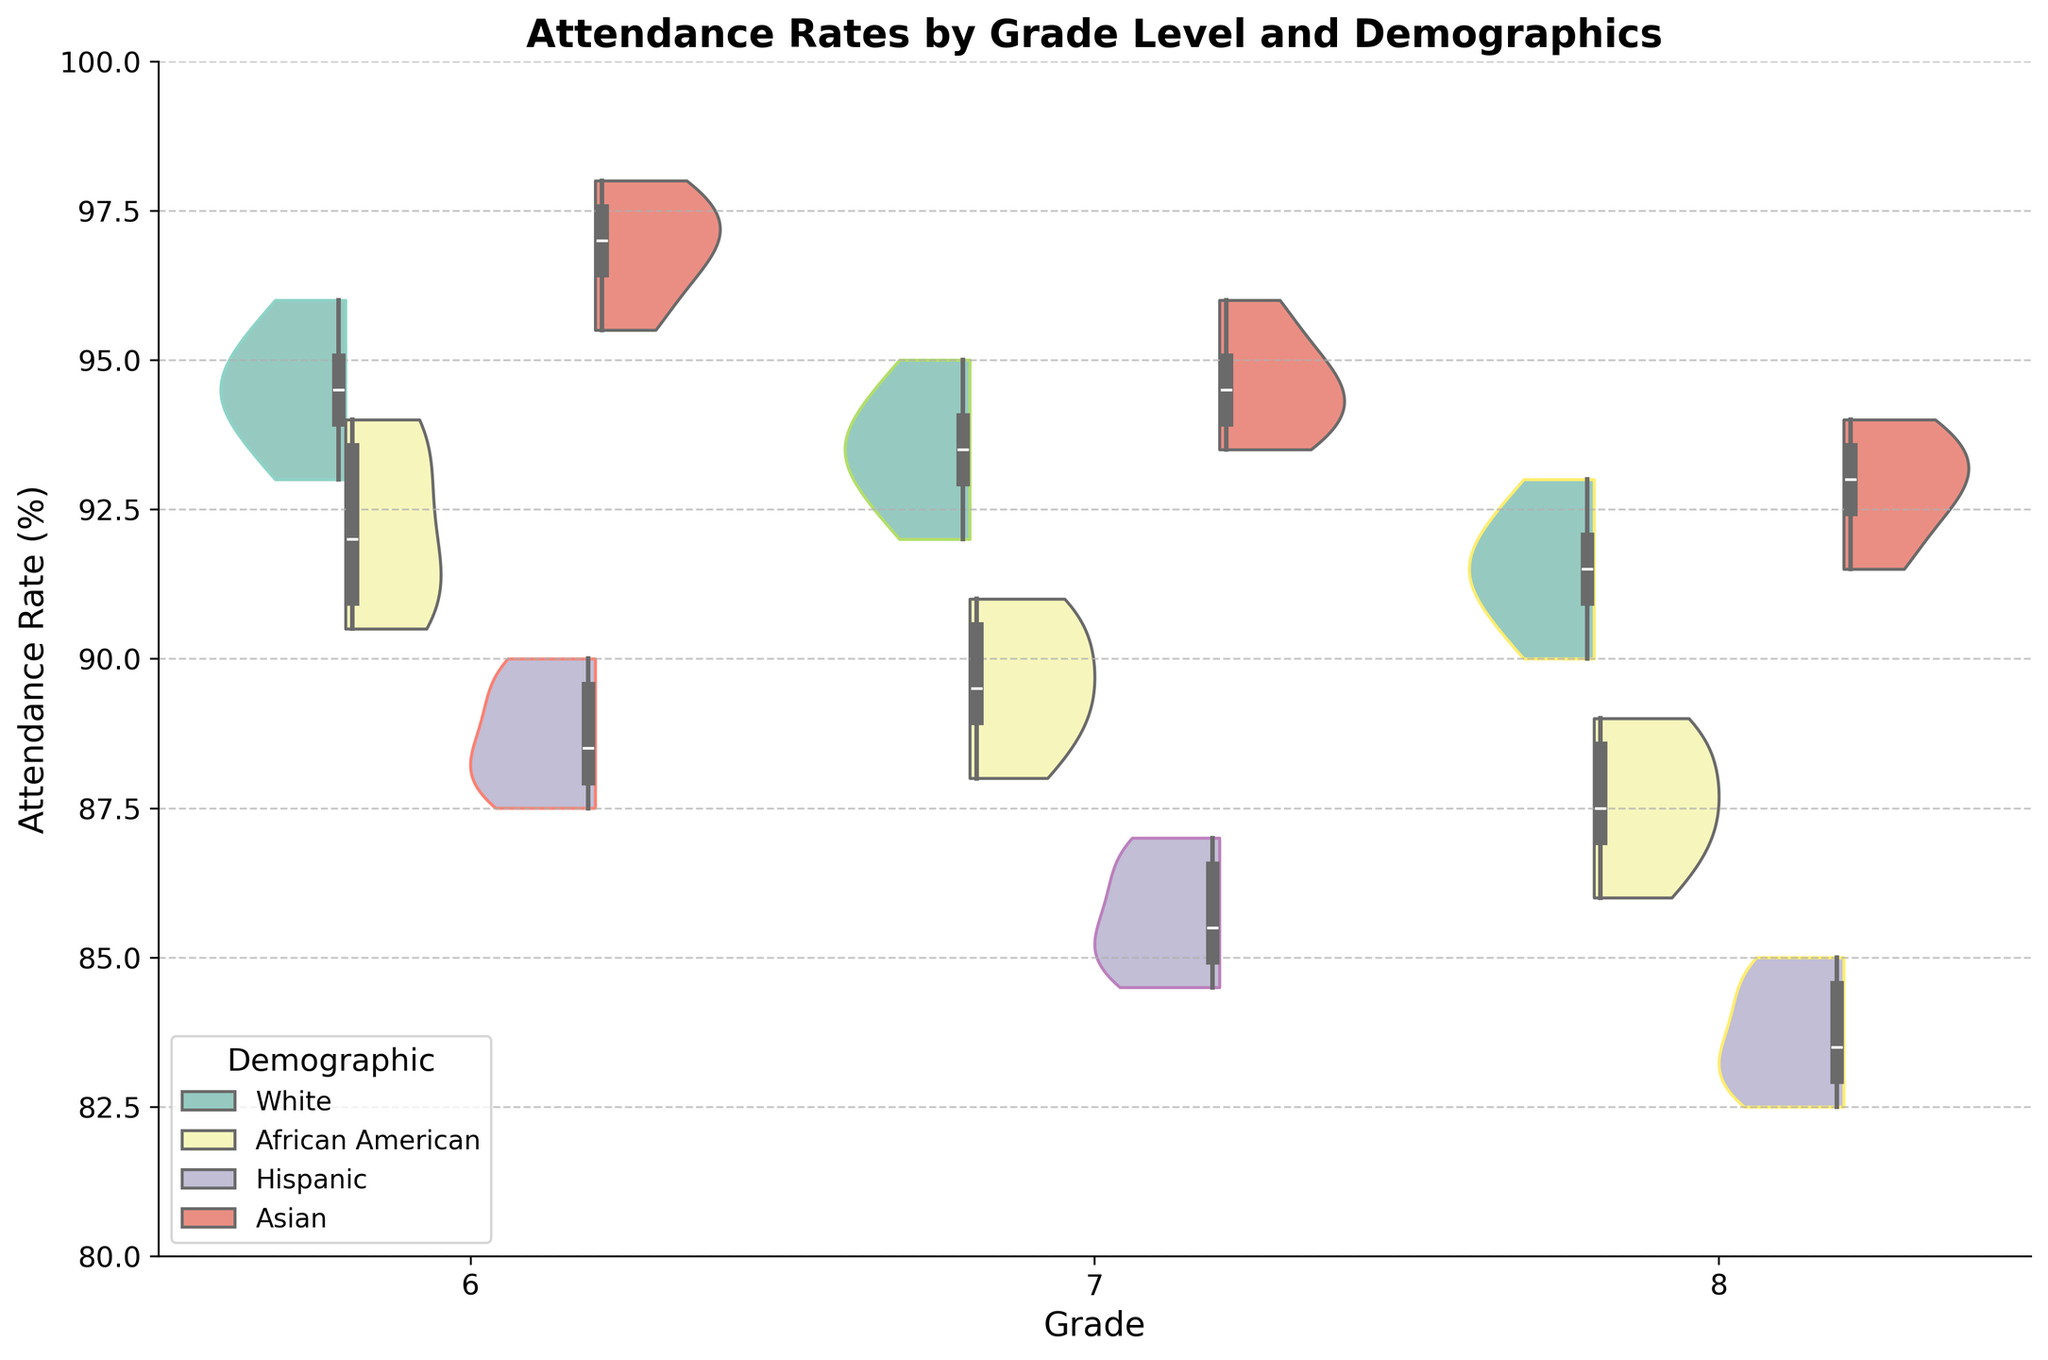What is the title of the figure? The title of the figure is displayed at the top and reads "Attendance Rates by Grade Level and Demographics".
Answer: Attendance Rates by Grade Level and Demographics Which demographic group shows the highest median attendance rate for grade 6? By observing the box plots overlaid on the violin plots, the group with the highest median attendance rate for grade 6 is the Asian demographic.
Answer: Asian How do the median attendance rates compare between the Asian and Hispanic demographics in grade 7? The box plots in the violin chart show that for grade 7, the median attendance rate for the Asian demographic is higher than that for the Hispanic demographic.
Answer: Asian median > Hispanic median What is the range of attendance rates for the African American demographic in grade 8? The range can be found by looking at the tips of the violin plot. For grade 8 African American students, the attendance rates range from 86.0% to 89.0%.
Answer: 86.0% to 89.0% Which grade's White demographic has the smallest spread in attendance rates? The spread can be determined by the width of the violin plots and the length of the box plots. The White demographic in grade 6 shows the smallest spread in attendance rates.
Answer: Grade 6 How does the attendance rate for the Hispanic demographic in grade 8 compare with the Hispanic demographic in grade 7? The median and the overall distribution can be compared directly using the violin plots. The attendance rate for the Hispanic demographic in grade 8 is lower than the Hispanic demographic in grade 7.
Answer: Grade 8 < Grade 7 Which demographic shows the widest spread of attendance rates for grade 6? By examining the width of the violin plots, the Hispanic demographic shows the widest spread of attendance rates for grade 6.
Answer: Hispanic What is the attendance rate at the lower quartile for the Asian demographic in grade 7? By examining the box plot inside the violin plot, the lower quartile (25th percentile) for the Asian demographic in grade 7 has an attendance rate around 94.0%.
Answer: 94.0% Is there a grade where the median attendance rates for all demographics are below 90%? By examining the box plots across all grades, no grade has median attendance rates for all demographics below 90%.
Answer: No Which demographic group in grade 8 has the highest variability in attendance rates? The variability can be observed by the width and spread of the violin plot. For grade 8, the Hispanic demographic group has the highest variability in attendance rates.
Answer: Hispanic 